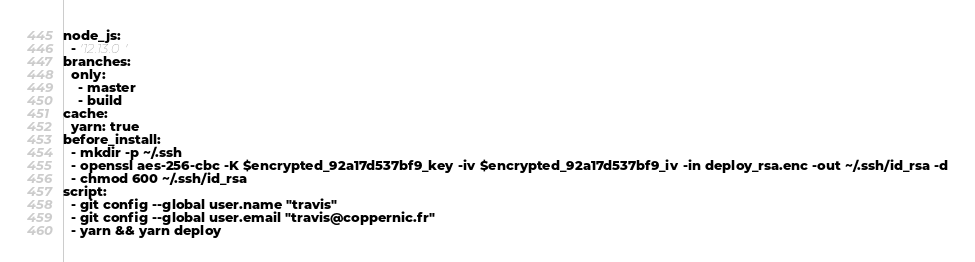Convert code to text. <code><loc_0><loc_0><loc_500><loc_500><_YAML_>node_js:
  - '12.13.0'
branches:
  only:
    - master
    - build
cache:
  yarn: true
before_install:
  - mkdir -p ~/.ssh
  - openssl aes-256-cbc -K $encrypted_92a17d537bf9_key -iv $encrypted_92a17d537bf9_iv -in deploy_rsa.enc -out ~/.ssh/id_rsa -d
  - chmod 600 ~/.ssh/id_rsa
script:
  - git config --global user.name "travis"
  - git config --global user.email "travis@coppernic.fr"
  - yarn && yarn deploy
</code> 